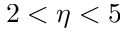<formula> <loc_0><loc_0><loc_500><loc_500>2 < \eta < 5</formula> 